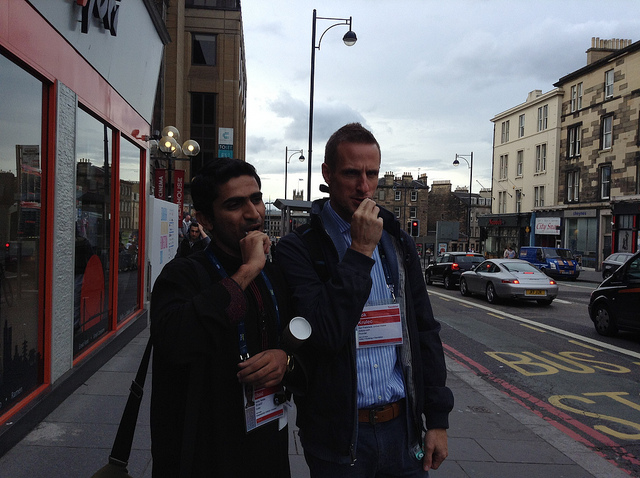Please transcribe the text in this image. BUS ST 